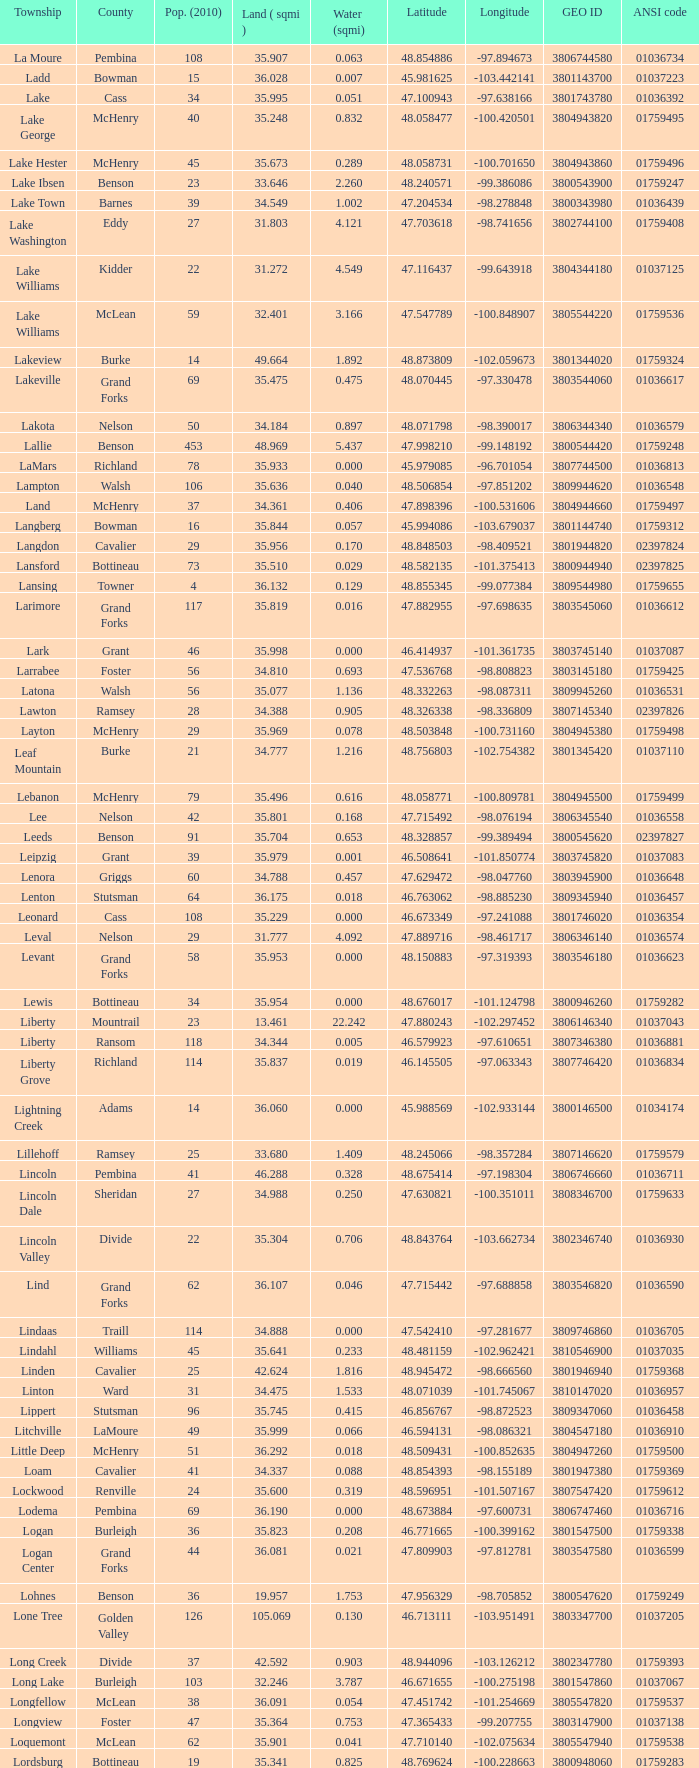What is latitude when 2010 population is 24 and water is more than 0.319? None. 